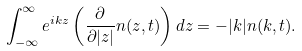Convert formula to latex. <formula><loc_0><loc_0><loc_500><loc_500>\int _ { - \infty } ^ { \infty } e ^ { i k z } \left ( \frac { \partial } { \partial | z | } n ( z , t ) \right ) d z = - | k | n ( k , t ) .</formula> 